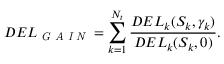<formula> <loc_0><loc_0><loc_500><loc_500>D E L _ { G A I N } = \sum _ { k = 1 } ^ { N _ { t } } \frac { D E L _ { k } ( S _ { k } , \gamma _ { k } ) } { D E L _ { k } ( S _ { k } , 0 ) } .</formula> 